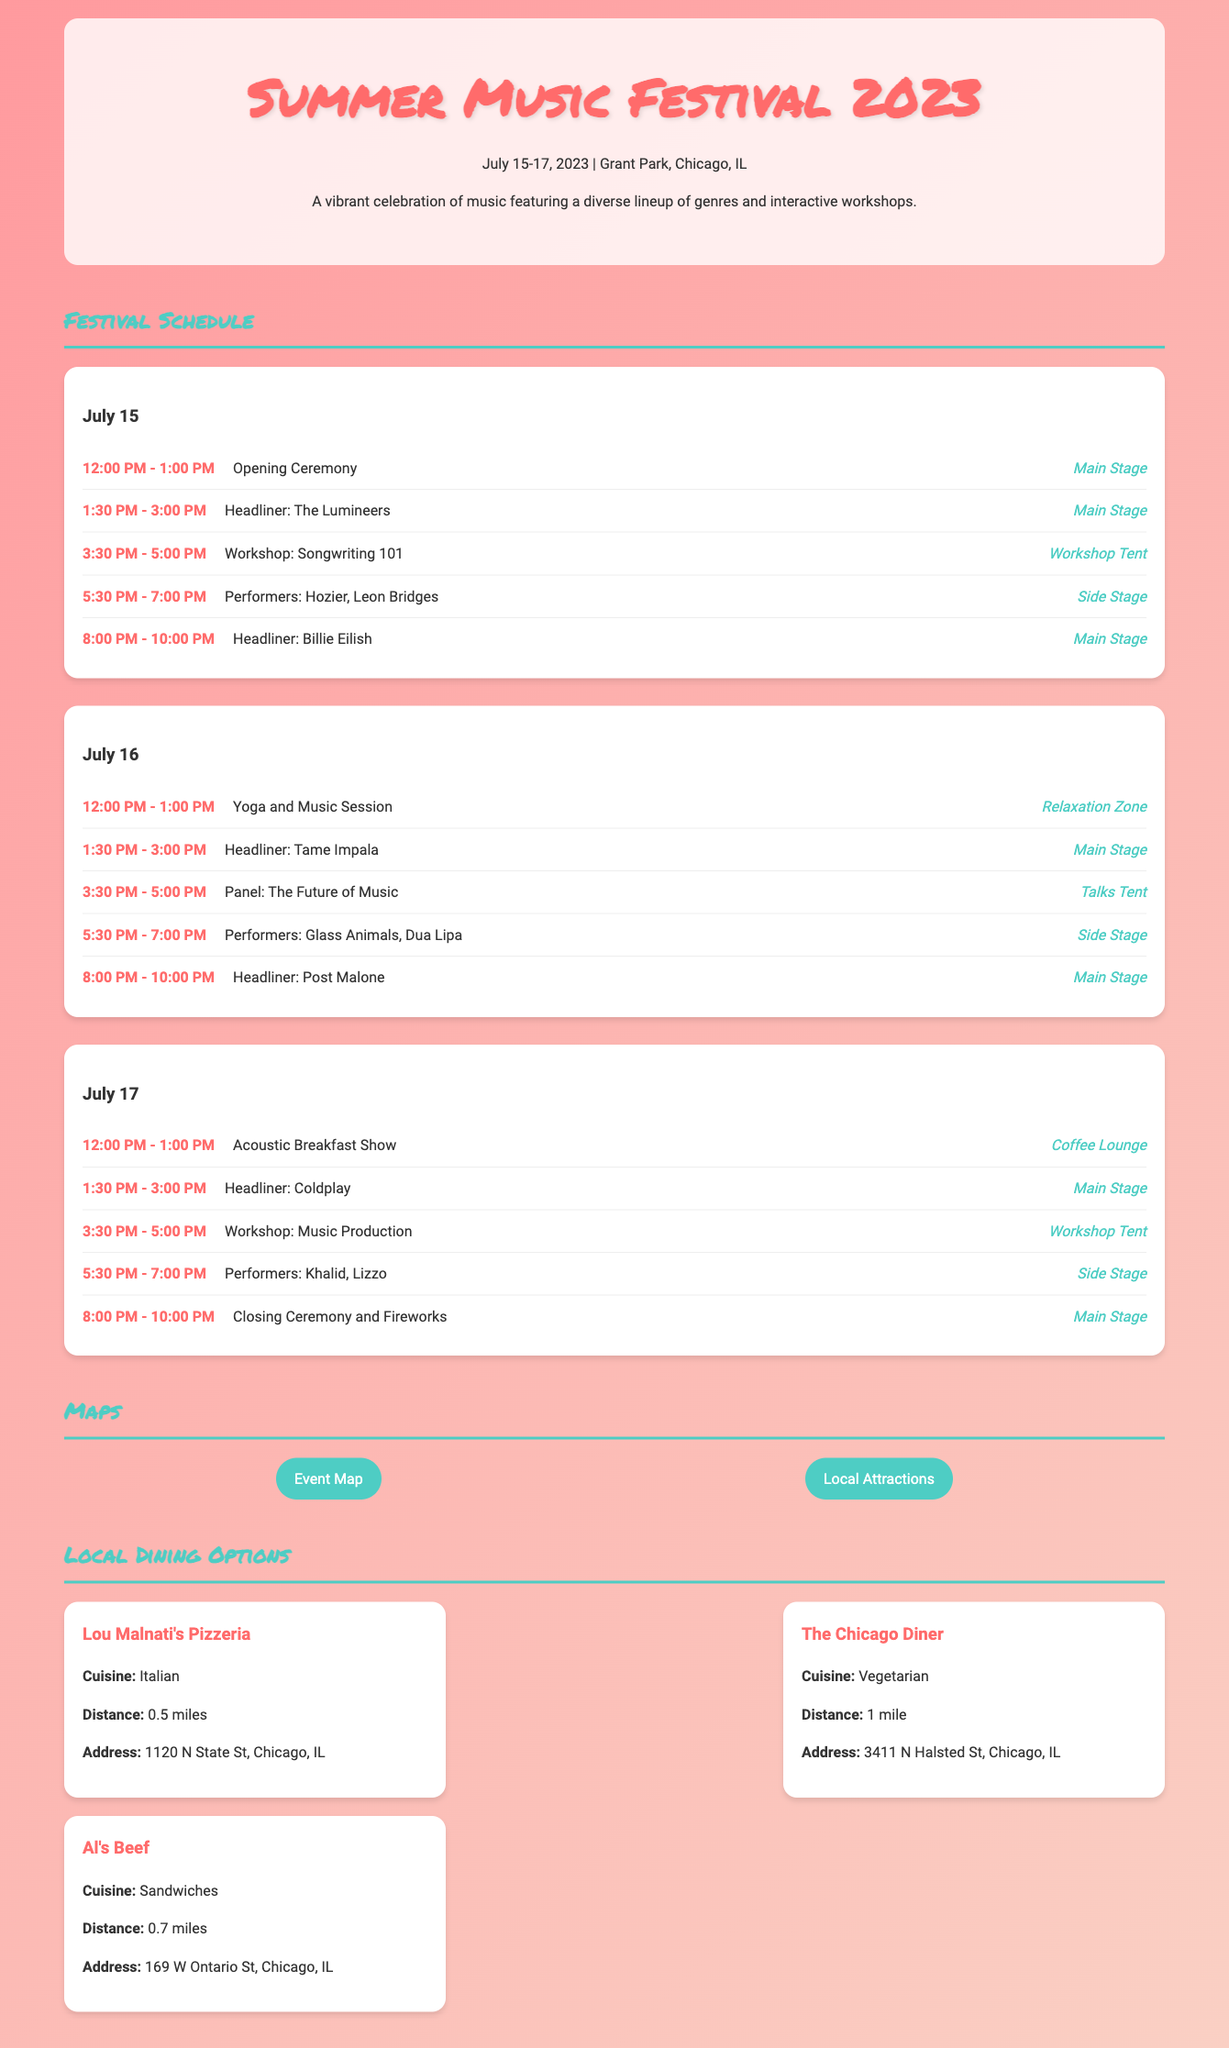What are the festival dates? The festival dates are specified at the top of the document in the header section.
Answer: July 15-17, 2023 Who is performing as the headliner on July 16? The headlined performer for July 16 is listed in the schedule under that date.
Answer: Tame Impala What time does the Acoustic Breakfast Show start on July 17? The starting time is indicated in the schedule for July 17.
Answer: 12:00 PM How many restaurants are listed in the local dining options? The number of restaurants can be counted in the local dining section.
Answer: 3 Where is Lou Malnati's Pizzeria located? The address of Lou Malnati's Pizzeria is mentioned in the dining options.
Answer: 1120 N State St, Chicago, IL What is the location of the closing ceremony? The schedule specifies where the closing ceremony will take place.
Answer: Main Stage Which workshop is available on July 15? The workshops are detailed in the daily schedules, and the specific one for July 15 is included.
Answer: Songwriting 101 What activity takes place at the Relaxation Zone on July 16? The schedule lists the specific activity happening in that location on July 16.
Answer: Yoga and Music Session 